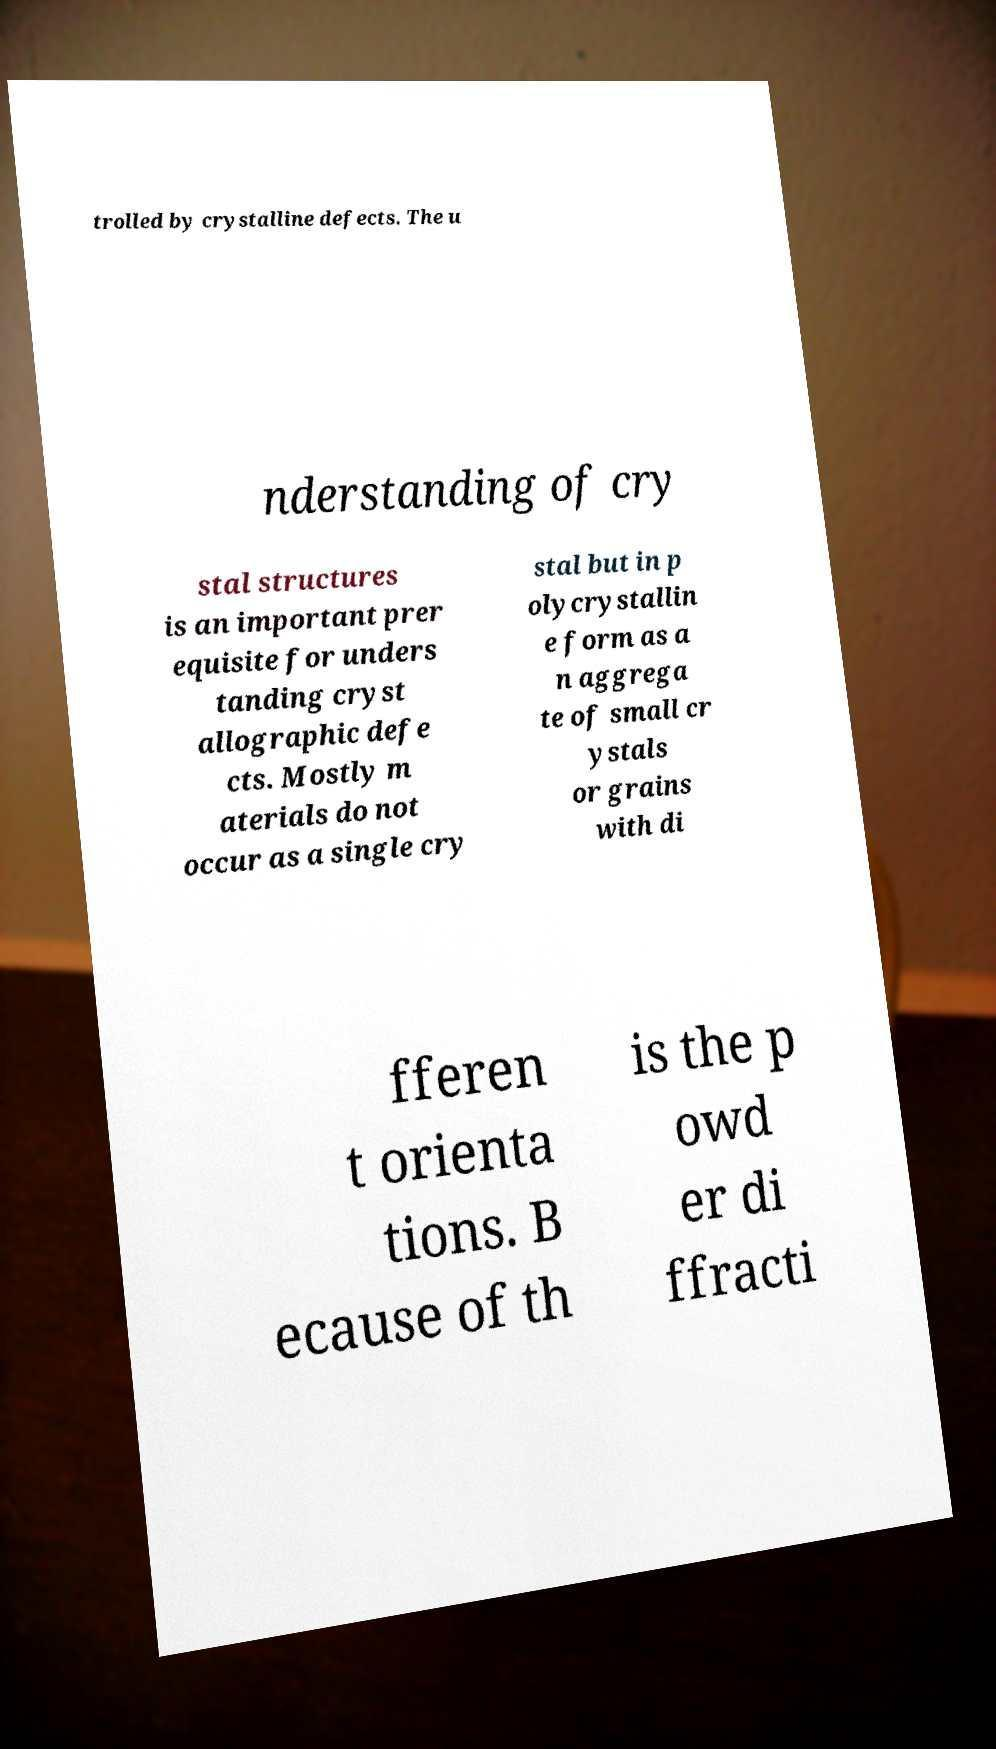Can you accurately transcribe the text from the provided image for me? trolled by crystalline defects. The u nderstanding of cry stal structures is an important prer equisite for unders tanding cryst allographic defe cts. Mostly m aterials do not occur as a single cry stal but in p olycrystallin e form as a n aggrega te of small cr ystals or grains with di fferen t orienta tions. B ecause of th is the p owd er di ffracti 